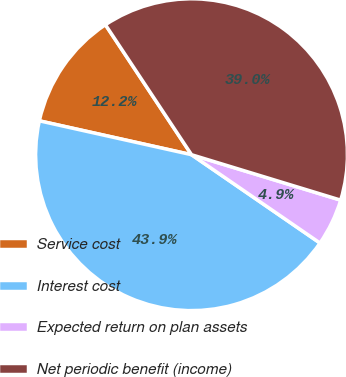Convert chart to OTSL. <chart><loc_0><loc_0><loc_500><loc_500><pie_chart><fcel>Service cost<fcel>Interest cost<fcel>Expected return on plan assets<fcel>Net periodic benefit (income)<nl><fcel>12.2%<fcel>43.9%<fcel>4.88%<fcel>39.02%<nl></chart> 